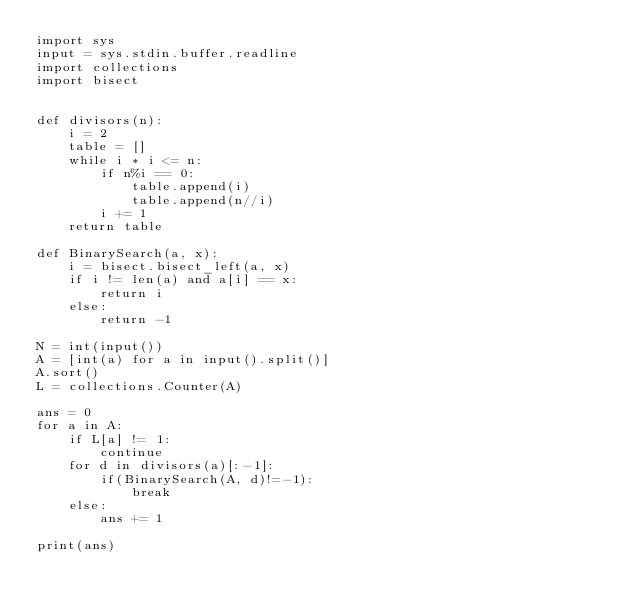<code> <loc_0><loc_0><loc_500><loc_500><_Python_>import sys
input = sys.stdin.buffer.readline
import collections
import bisect


def divisors(n):
    i = 2
    table = []
    while i * i <= n:
        if n%i == 0:
            table.append(i)
            table.append(n//i)
        i += 1
    return table

def BinarySearch(a, x): 
    i = bisect.bisect_left(a, x) 
    if i != len(a) and a[i] == x: 
        return i 
    else: 
        return -1

N = int(input())
A = [int(a) for a in input().split()]
A.sort()
L = collections.Counter(A)

ans = 0
for a in A:
    if L[a] != 1:
        continue
    for d in divisors(a)[:-1]:
        if(BinarySearch(A, d)!=-1):
            break
    else:
        ans += 1

print(ans)</code> 